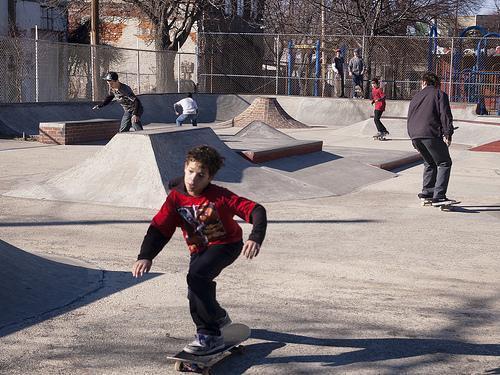How many people are in the skate park?
Give a very brief answer. 7. 